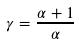<formula> <loc_0><loc_0><loc_500><loc_500>\gamma = \frac { \alpha + 1 } { \alpha }</formula> 